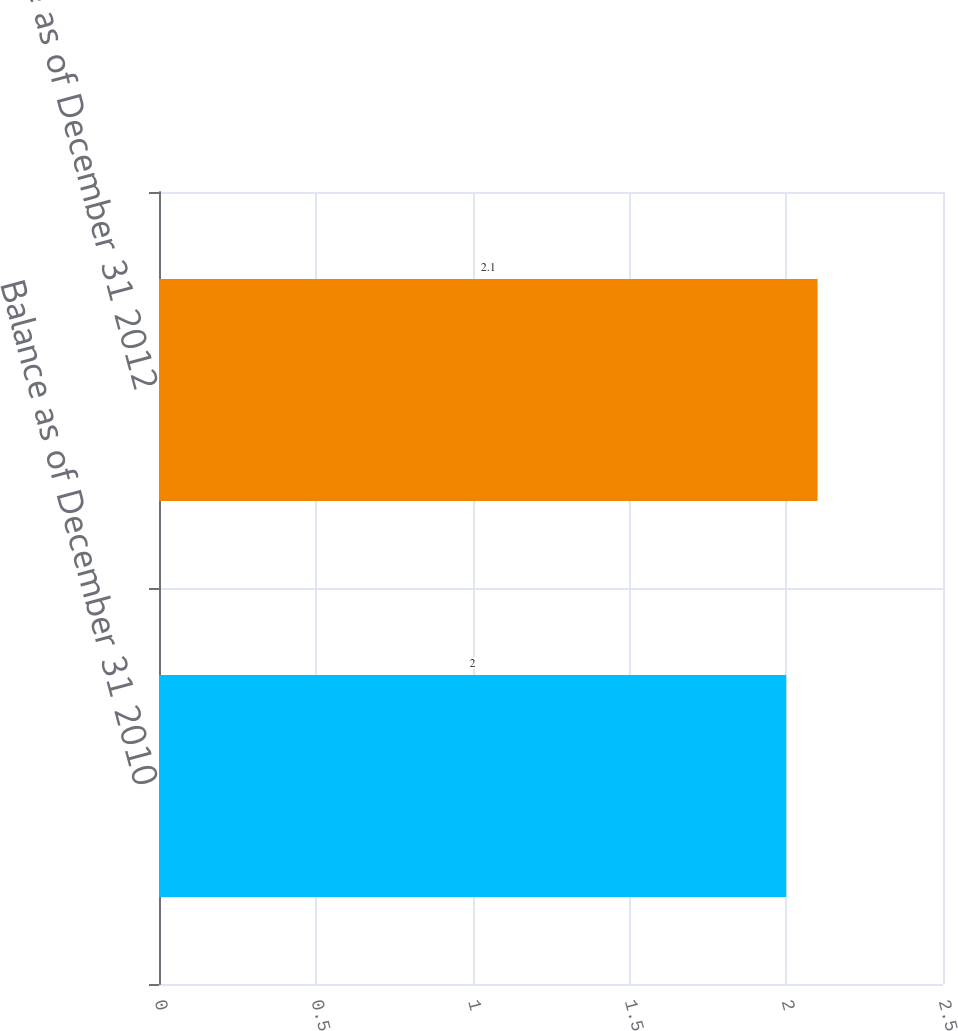<chart> <loc_0><loc_0><loc_500><loc_500><bar_chart><fcel>Balance as of December 31 2010<fcel>Balance as of December 31 2012<nl><fcel>2<fcel>2.1<nl></chart> 